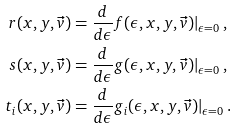<formula> <loc_0><loc_0><loc_500><loc_500>r ( x , y , \vec { v } ) & = \frac { d } { d \epsilon } f ( \epsilon , x , y , \vec { v } ) | _ { \epsilon = 0 } \, , \\ s ( x , y , \vec { v } ) & = \frac { d } { d \epsilon } g ( \epsilon , x , y , \vec { v } ) | _ { \epsilon = 0 } \, , \\ t _ { i } ( x , y , \vec { v } ) & = \frac { d } { d \epsilon } g _ { i } ( \epsilon , x , y , \vec { v } ) | _ { \epsilon = 0 } \, .</formula> 